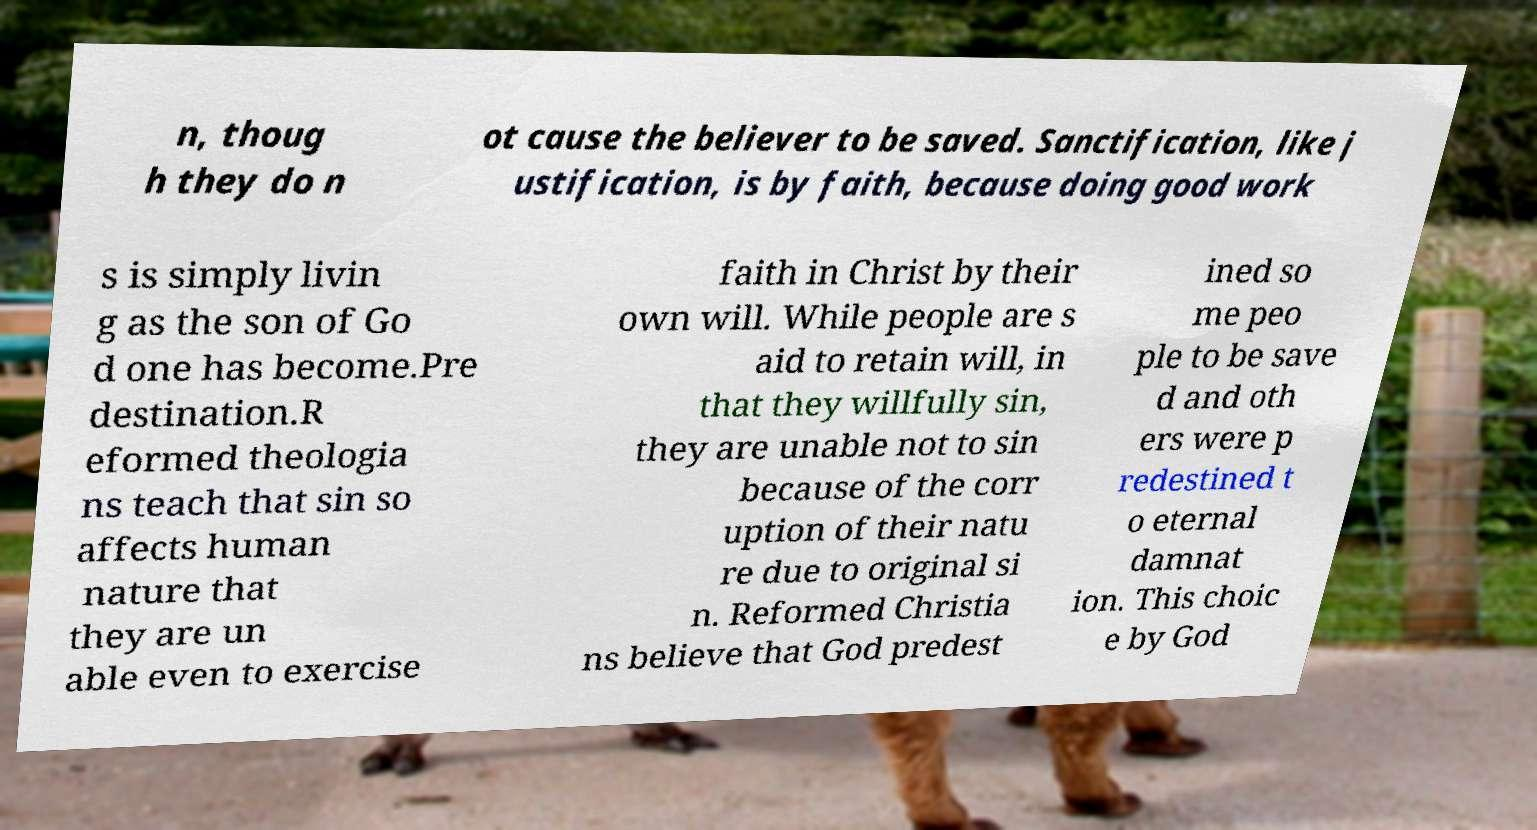Please read and relay the text visible in this image. What does it say? n, thoug h they do n ot cause the believer to be saved. Sanctification, like j ustification, is by faith, because doing good work s is simply livin g as the son of Go d one has become.Pre destination.R eformed theologia ns teach that sin so affects human nature that they are un able even to exercise faith in Christ by their own will. While people are s aid to retain will, in that they willfully sin, they are unable not to sin because of the corr uption of their natu re due to original si n. Reformed Christia ns believe that God predest ined so me peo ple to be save d and oth ers were p redestined t o eternal damnat ion. This choic e by God 